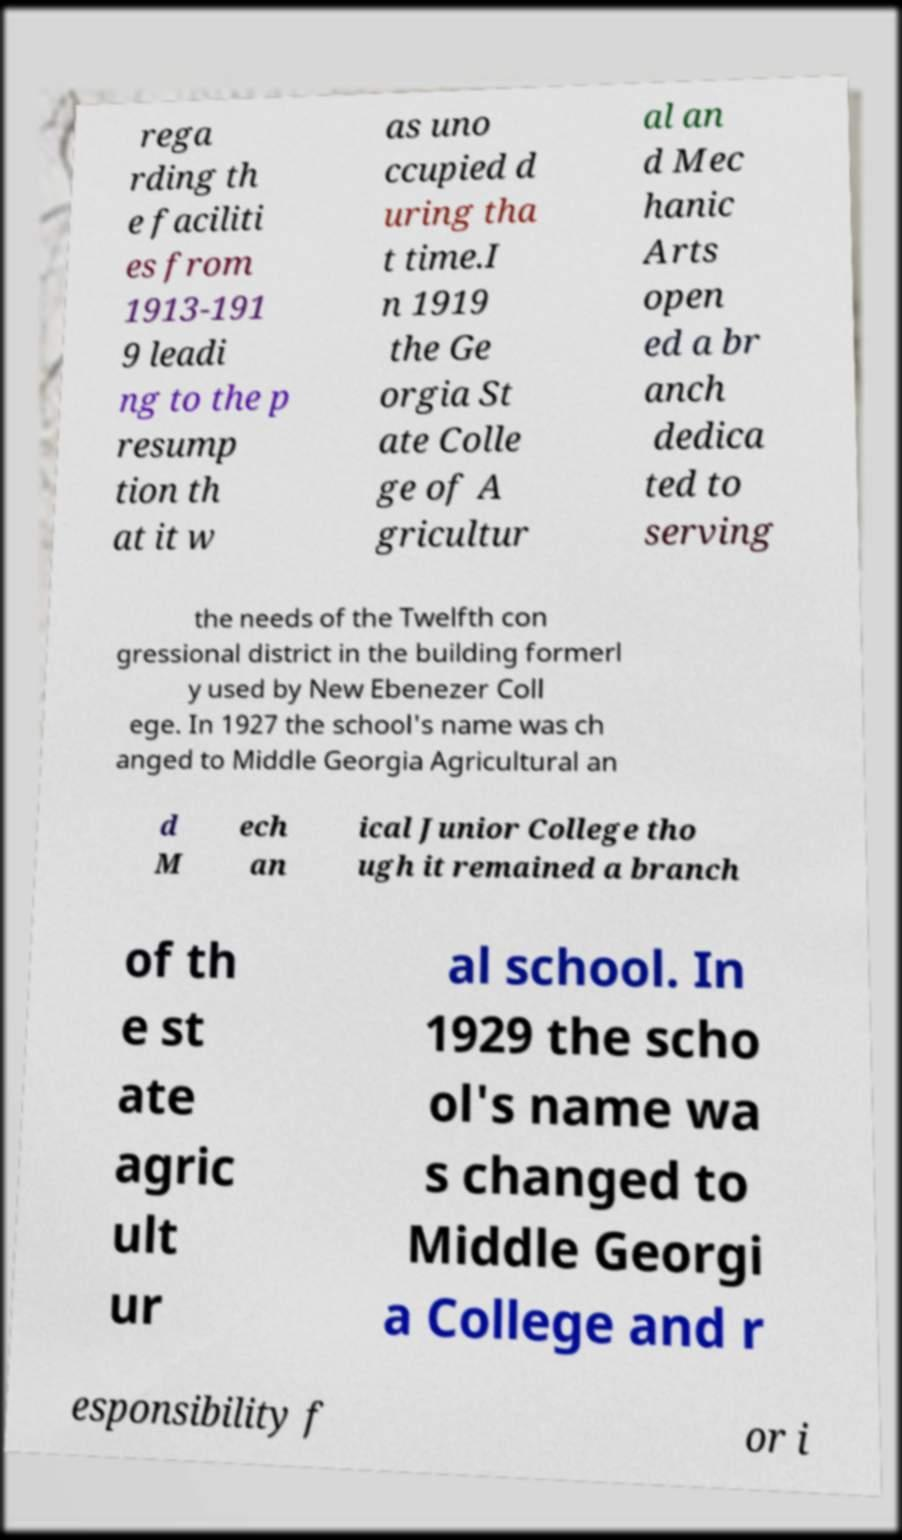I need the written content from this picture converted into text. Can you do that? rega rding th e faciliti es from 1913-191 9 leadi ng to the p resump tion th at it w as uno ccupied d uring tha t time.I n 1919 the Ge orgia St ate Colle ge of A gricultur al an d Mec hanic Arts open ed a br anch dedica ted to serving the needs of the Twelfth con gressional district in the building formerl y used by New Ebenezer Coll ege. In 1927 the school's name was ch anged to Middle Georgia Agricultural an d M ech an ical Junior College tho ugh it remained a branch of th e st ate agric ult ur al school. In 1929 the scho ol's name wa s changed to Middle Georgi a College and r esponsibility f or i 